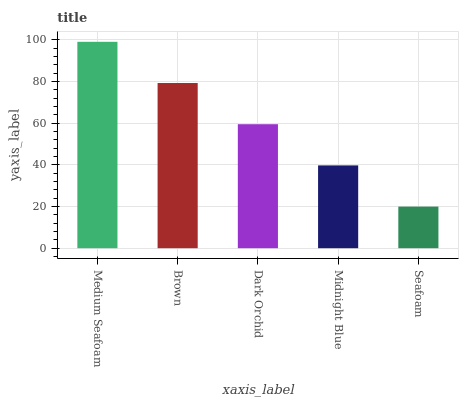Is Seafoam the minimum?
Answer yes or no. Yes. Is Medium Seafoam the maximum?
Answer yes or no. Yes. Is Brown the minimum?
Answer yes or no. No. Is Brown the maximum?
Answer yes or no. No. Is Medium Seafoam greater than Brown?
Answer yes or no. Yes. Is Brown less than Medium Seafoam?
Answer yes or no. Yes. Is Brown greater than Medium Seafoam?
Answer yes or no. No. Is Medium Seafoam less than Brown?
Answer yes or no. No. Is Dark Orchid the high median?
Answer yes or no. Yes. Is Dark Orchid the low median?
Answer yes or no. Yes. Is Brown the high median?
Answer yes or no. No. Is Brown the low median?
Answer yes or no. No. 